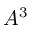Convert formula to latex. <formula><loc_0><loc_0><loc_500><loc_500>A ^ { 3 }</formula> 